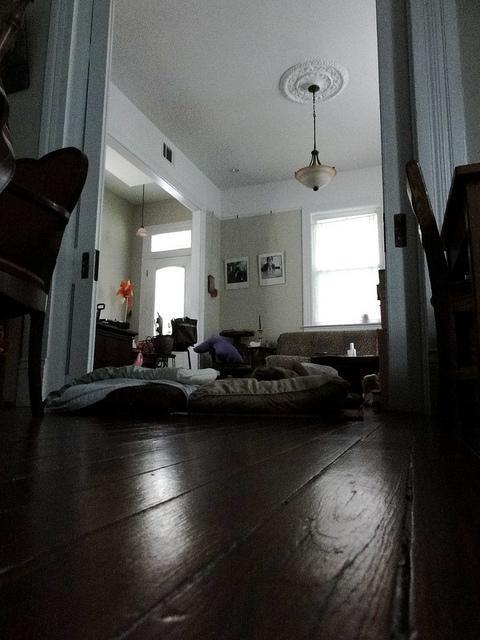What is the highest object in the room?
Indicate the correct response by choosing from the four available options to answer the question.
Options: Couch, hanging light, dog bed, table. Hanging light. 